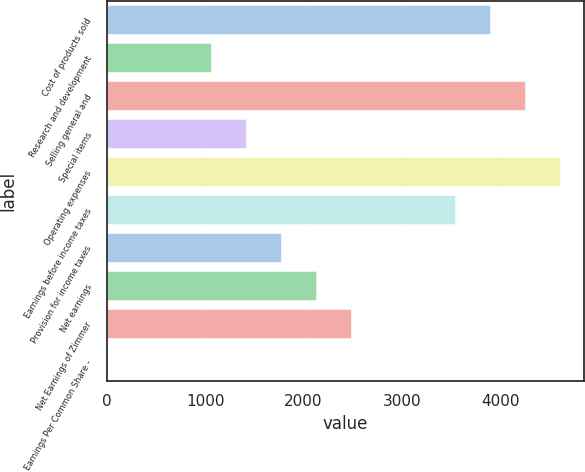<chart> <loc_0><loc_0><loc_500><loc_500><bar_chart><fcel>Cost of products sold<fcel>Research and development<fcel>Selling general and<fcel>Special items<fcel>Operating expenses<fcel>Earnings before income taxes<fcel>Provision for income taxes<fcel>Net earnings<fcel>Net Earnings of Zimmer<fcel>Earnings Per Common Share -<nl><fcel>3909.87<fcel>1069.63<fcel>4264.9<fcel>1424.66<fcel>4619.93<fcel>3554.84<fcel>1779.69<fcel>2134.72<fcel>2489.75<fcel>4.54<nl></chart> 